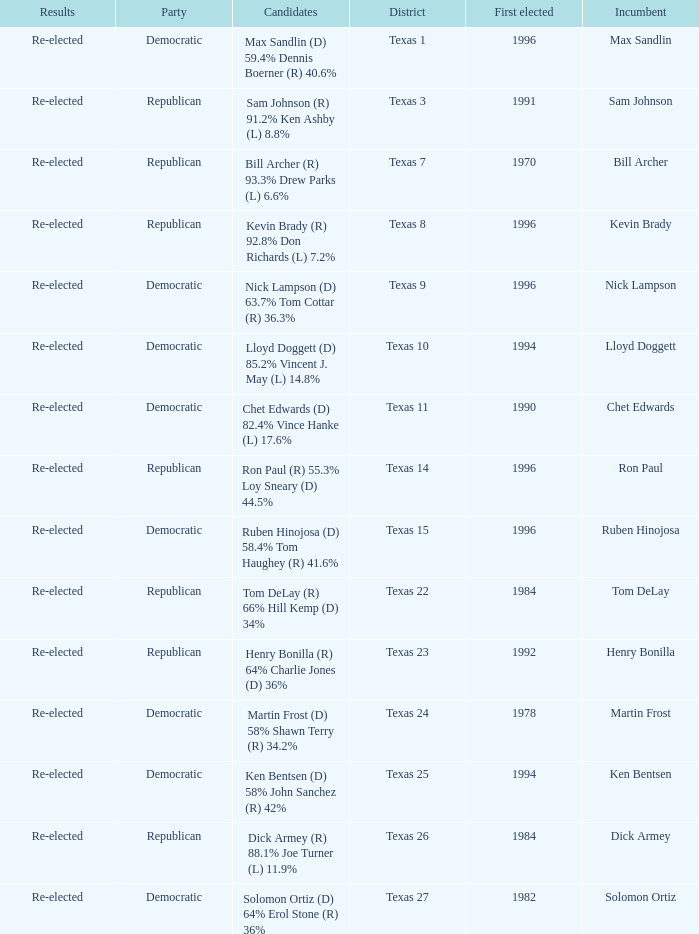What district is nick lampson from? Texas 9. 